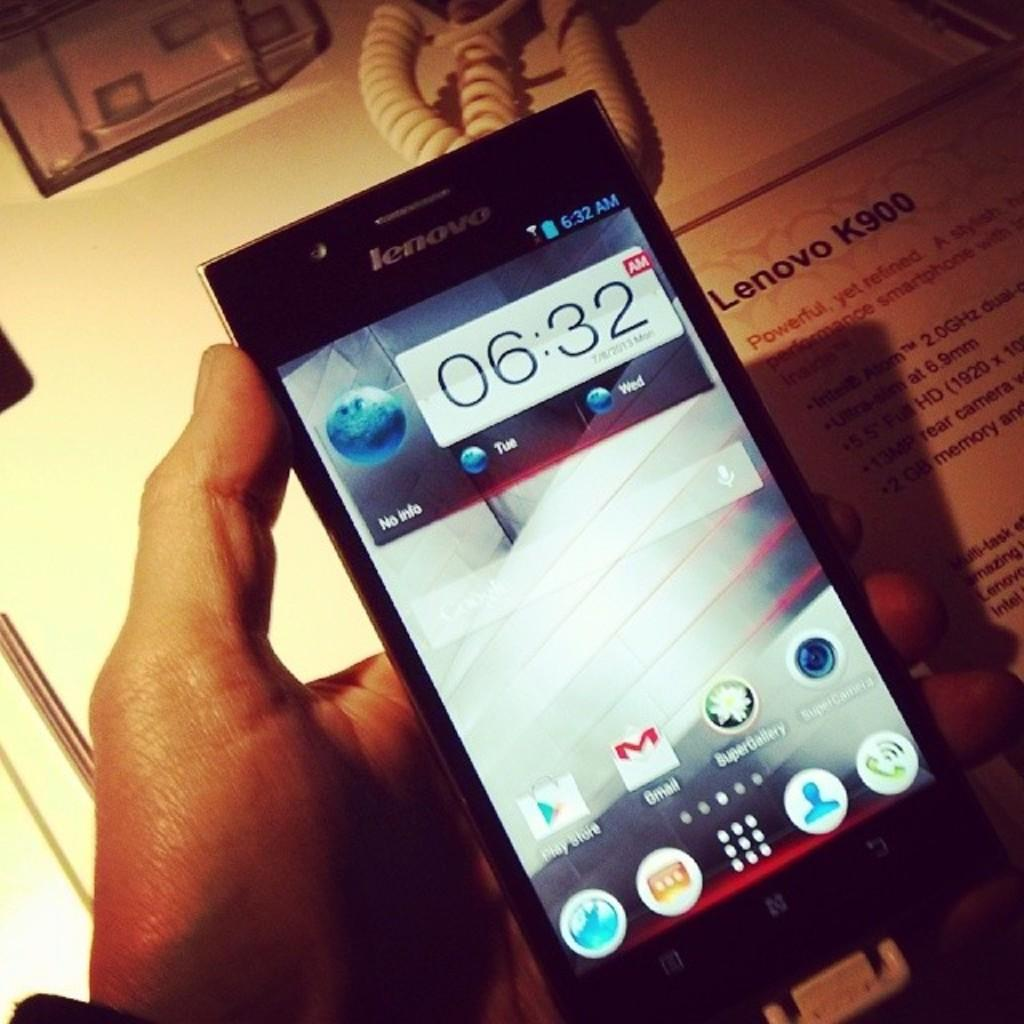What is the main subject in the foreground of the image? There is a person in the foreground of the image. What is the person holding in the image? The person is holding a mobile phone. What can be seen in the background of the image? There is a table and a board in the background of the image. How many chickens are on the board in the image? There are no chickens present in the image, and the board does not have any chickens on it. 